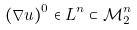<formula> <loc_0><loc_0><loc_500><loc_500>( \nabla u ) ^ { 0 } \in L ^ { n } \subset \mathcal { M } ^ { n } _ { 2 }</formula> 